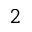Convert formula to latex. <formula><loc_0><loc_0><loc_500><loc_500>^ { 2 }</formula> 